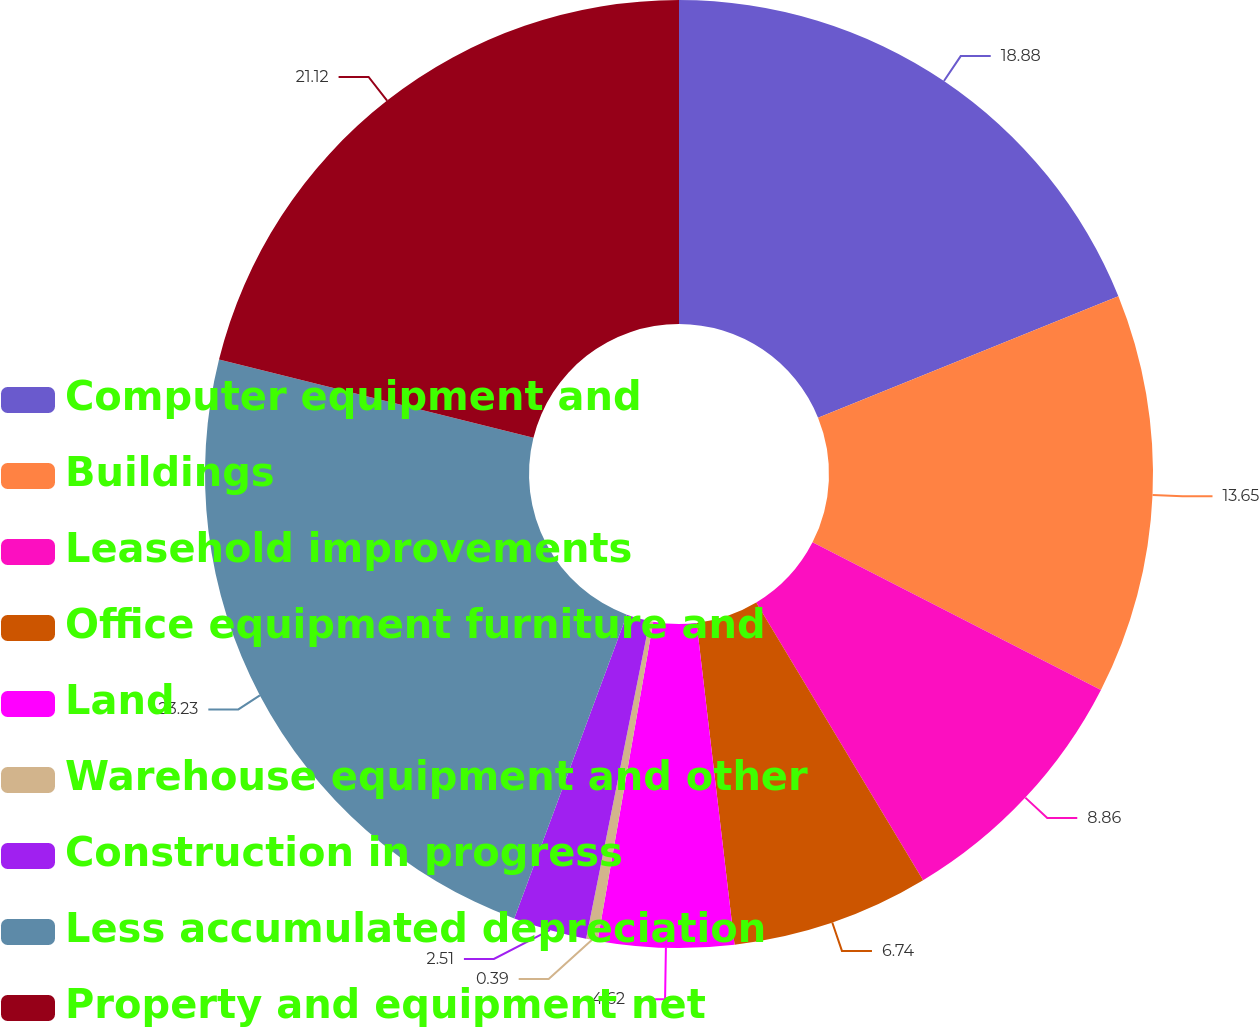Convert chart to OTSL. <chart><loc_0><loc_0><loc_500><loc_500><pie_chart><fcel>Computer equipment and<fcel>Buildings<fcel>Leasehold improvements<fcel>Office equipment furniture and<fcel>Land<fcel>Warehouse equipment and other<fcel>Construction in progress<fcel>Less accumulated depreciation<fcel>Property and equipment net<nl><fcel>18.88%<fcel>13.65%<fcel>8.86%<fcel>6.74%<fcel>4.62%<fcel>0.39%<fcel>2.51%<fcel>23.23%<fcel>21.12%<nl></chart> 